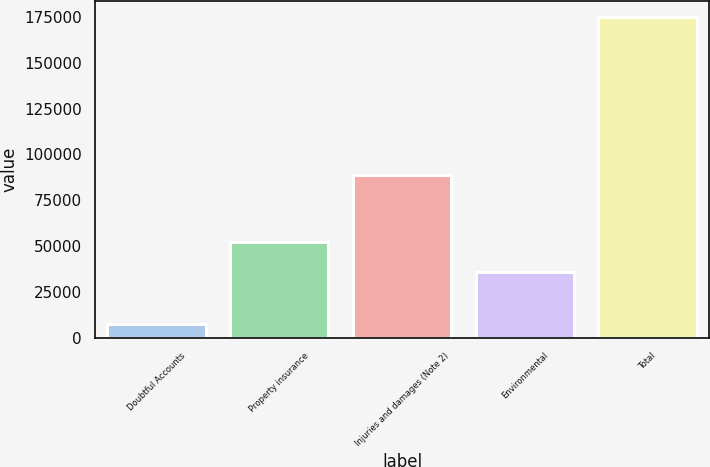<chart> <loc_0><loc_0><loc_500><loc_500><bar_chart><fcel>Doubtful Accounts<fcel>Property insurance<fcel>Injuries and damages (Note 2)<fcel>Environmental<fcel>Total<nl><fcel>7697<fcel>52482.3<fcel>88739<fcel>35729<fcel>175230<nl></chart> 